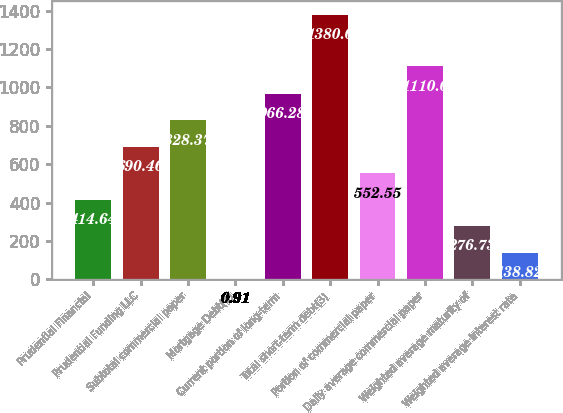Convert chart to OTSL. <chart><loc_0><loc_0><loc_500><loc_500><bar_chart><fcel>Prudential Financial<fcel>Prudential Funding LLC<fcel>Subtotal commercial paper<fcel>Mortgage Debt(1)<fcel>Current portion of long-term<fcel>Total short-term debt(3)<fcel>Portion of commercial paper<fcel>Daily average commercial paper<fcel>Weighted average maturity of<fcel>Weighted average interest rate<nl><fcel>414.64<fcel>690.46<fcel>828.37<fcel>0.91<fcel>966.28<fcel>1380<fcel>552.55<fcel>1110<fcel>276.73<fcel>138.82<nl></chart> 